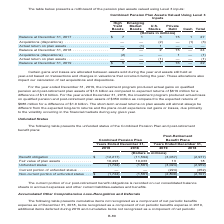According to Centurylink's financial document, Where is the current portion of the post-retirement benefit obligations recorded? recorded on our consolidated balance sheets in accrued expenses and other current liabilities-salaries and benefits. The document states: "ion of our post-retirement benefit obligations is recorded on our consolidated balance sheets in accrued expenses and other current liabilities-salari..." Also, What is the fair value of plan assets for the combined pension plan item in 2019? According to the financial document, 10,493 (in millions). The relevant text states: ",594) (3,037) (2,977) Fair value of plan assets . 10,493 10,033 13 18..." Also, The unfunded statuses of which items are presented in the table? The document shows two values: Combined Pension Plan and Post-Retirement Benefit Plans. From the document: "unfunded status of the Combined Pension Plan and post-retirement benefit plans: Combined Pension Plan Assets Valued Using Level 3 Inputs..." Additionally, In which year is the fair value of plan assets under post-retirement benefit plans higher? According to the financial document, 2018. The relevant text states: "2019 2018 2019 2018..." Also, can you calculate: What is the difference in the fair value of plan assets under the combined pension plan in 2019? Based on the calculation: 10,493-10,033, the result is 460 (in millions). This is based on the information: ",594) (3,037) (2,977) Fair value of plan assets . 10,493 10,033 13 18 3,037) (2,977) Fair value of plan assets . 10,493 10,033 13 18..." The key data points involved are: 10,033, 10,493. Also, can you calculate: What is the percentage difference in the fair value of plan assets under the combined pension plan in 2019? To answer this question, I need to perform calculations using the financial data. The calculation is: (10,493-10,033)/10,033, which equals 4.58 (percentage). This is based on the information: ",594) (3,037) (2,977) Fair value of plan assets . 10,493 10,033 13 18 3,037) (2,977) Fair value of plan assets . 10,493 10,033 13 18..." The key data points involved are: 10,033, 10,493. 